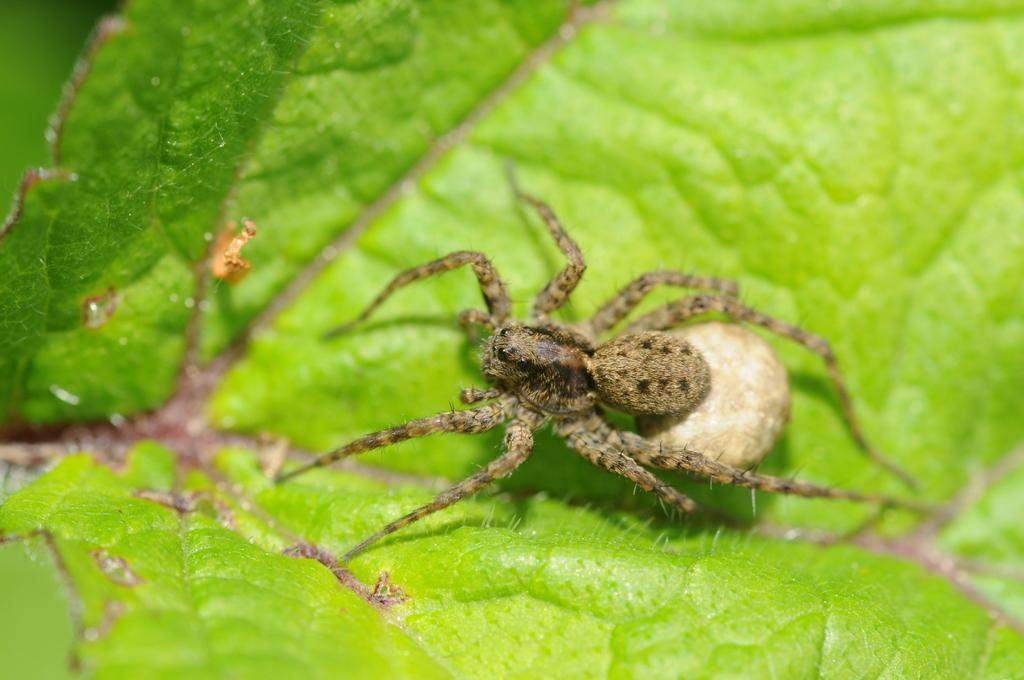What type of plant material is present in the image? There is a green leaf in the image. Is there any animal life visible on the leaf? Yes, there is a spider on the green leaf. What type of key is being used to feed the dog in the image? There is no key or dog present in the image; it only features a green leaf with a spider on it. 